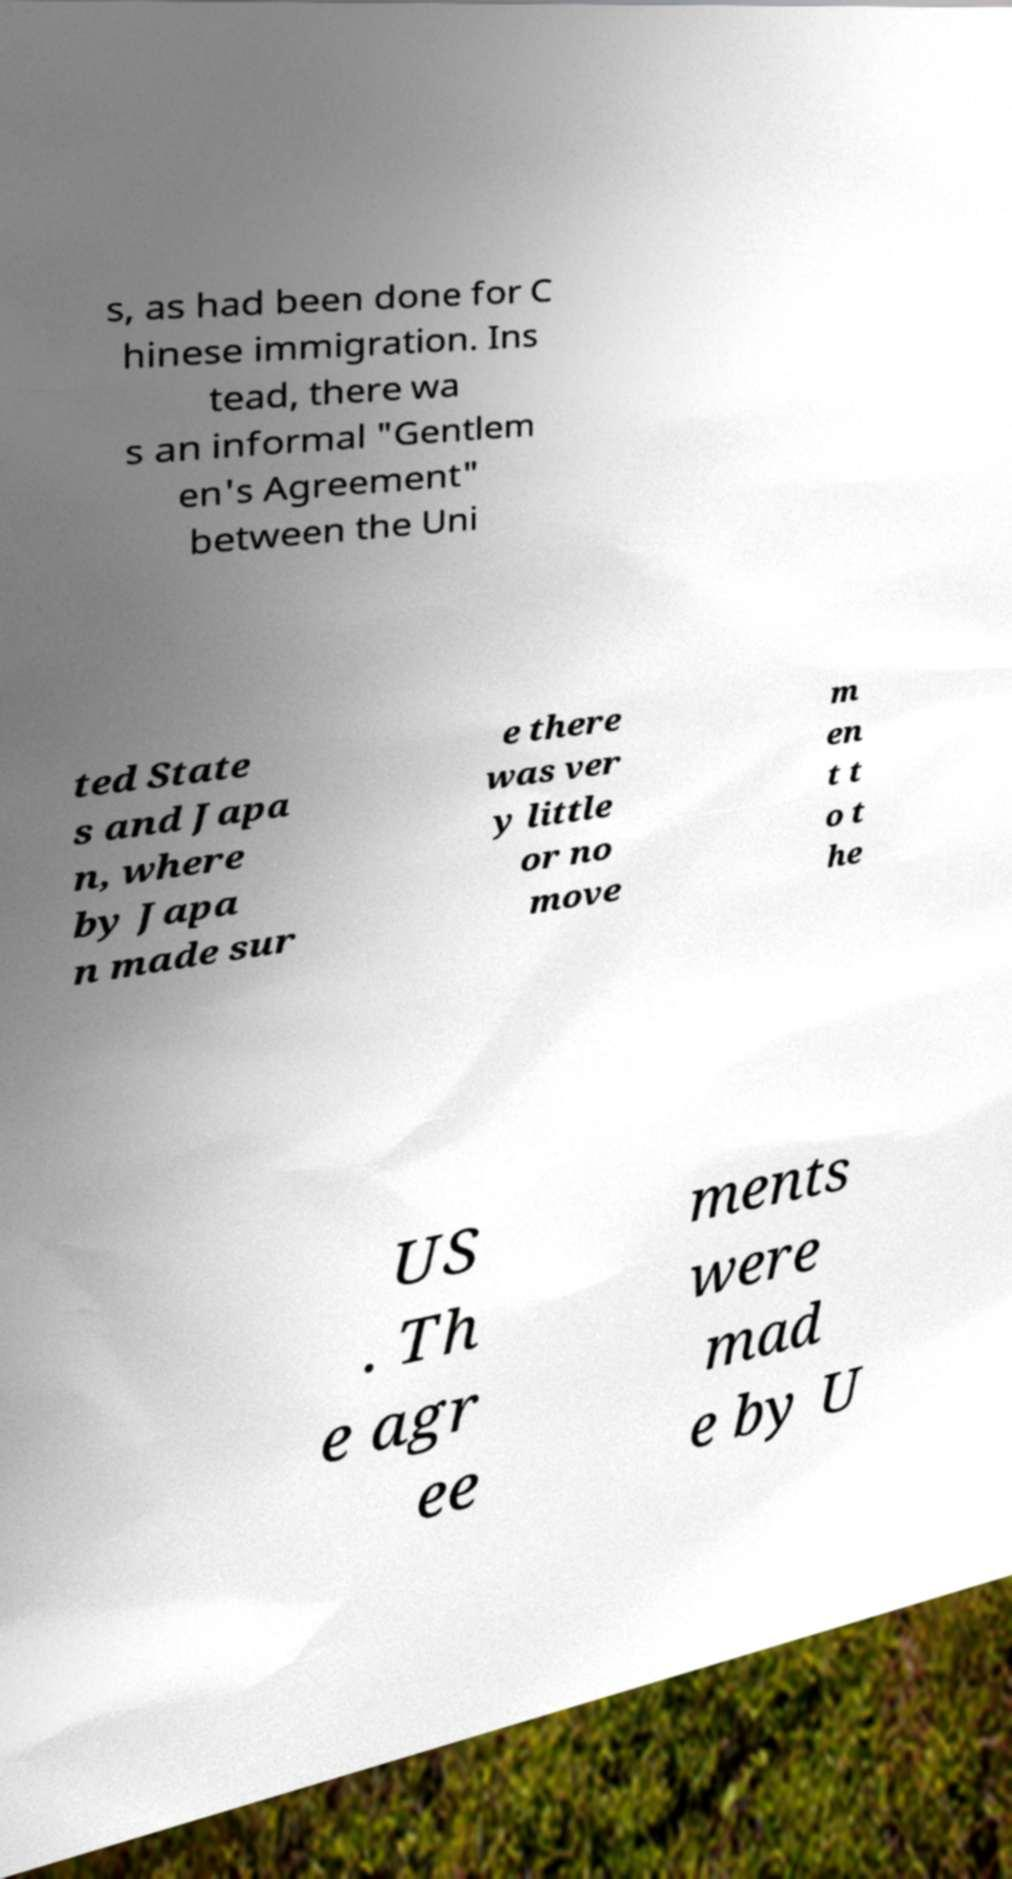Could you assist in decoding the text presented in this image and type it out clearly? s, as had been done for C hinese immigration. Ins tead, there wa s an informal "Gentlem en's Agreement" between the Uni ted State s and Japa n, where by Japa n made sur e there was ver y little or no move m en t t o t he US . Th e agr ee ments were mad e by U 